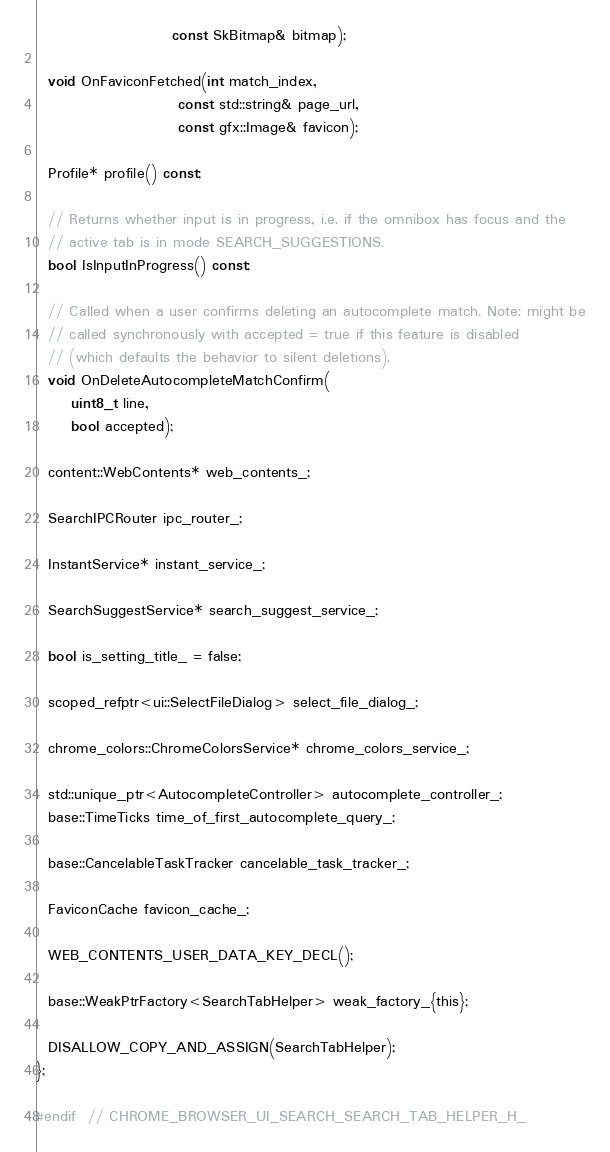Convert code to text. <code><loc_0><loc_0><loc_500><loc_500><_C_>                       const SkBitmap& bitmap);

  void OnFaviconFetched(int match_index,
                        const std::string& page_url,
                        const gfx::Image& favicon);

  Profile* profile() const;

  // Returns whether input is in progress, i.e. if the omnibox has focus and the
  // active tab is in mode SEARCH_SUGGESTIONS.
  bool IsInputInProgress() const;

  // Called when a user confirms deleting an autocomplete match. Note: might be
  // called synchronously with accepted = true if this feature is disabled
  // (which defaults the behavior to silent deletions).
  void OnDeleteAutocompleteMatchConfirm(
      uint8_t line,
      bool accepted);

  content::WebContents* web_contents_;

  SearchIPCRouter ipc_router_;

  InstantService* instant_service_;

  SearchSuggestService* search_suggest_service_;

  bool is_setting_title_ = false;

  scoped_refptr<ui::SelectFileDialog> select_file_dialog_;

  chrome_colors::ChromeColorsService* chrome_colors_service_;

  std::unique_ptr<AutocompleteController> autocomplete_controller_;
  base::TimeTicks time_of_first_autocomplete_query_;

  base::CancelableTaskTracker cancelable_task_tracker_;

  FaviconCache favicon_cache_;

  WEB_CONTENTS_USER_DATA_KEY_DECL();

  base::WeakPtrFactory<SearchTabHelper> weak_factory_{this};

  DISALLOW_COPY_AND_ASSIGN(SearchTabHelper);
};

#endif  // CHROME_BROWSER_UI_SEARCH_SEARCH_TAB_HELPER_H_
</code> 